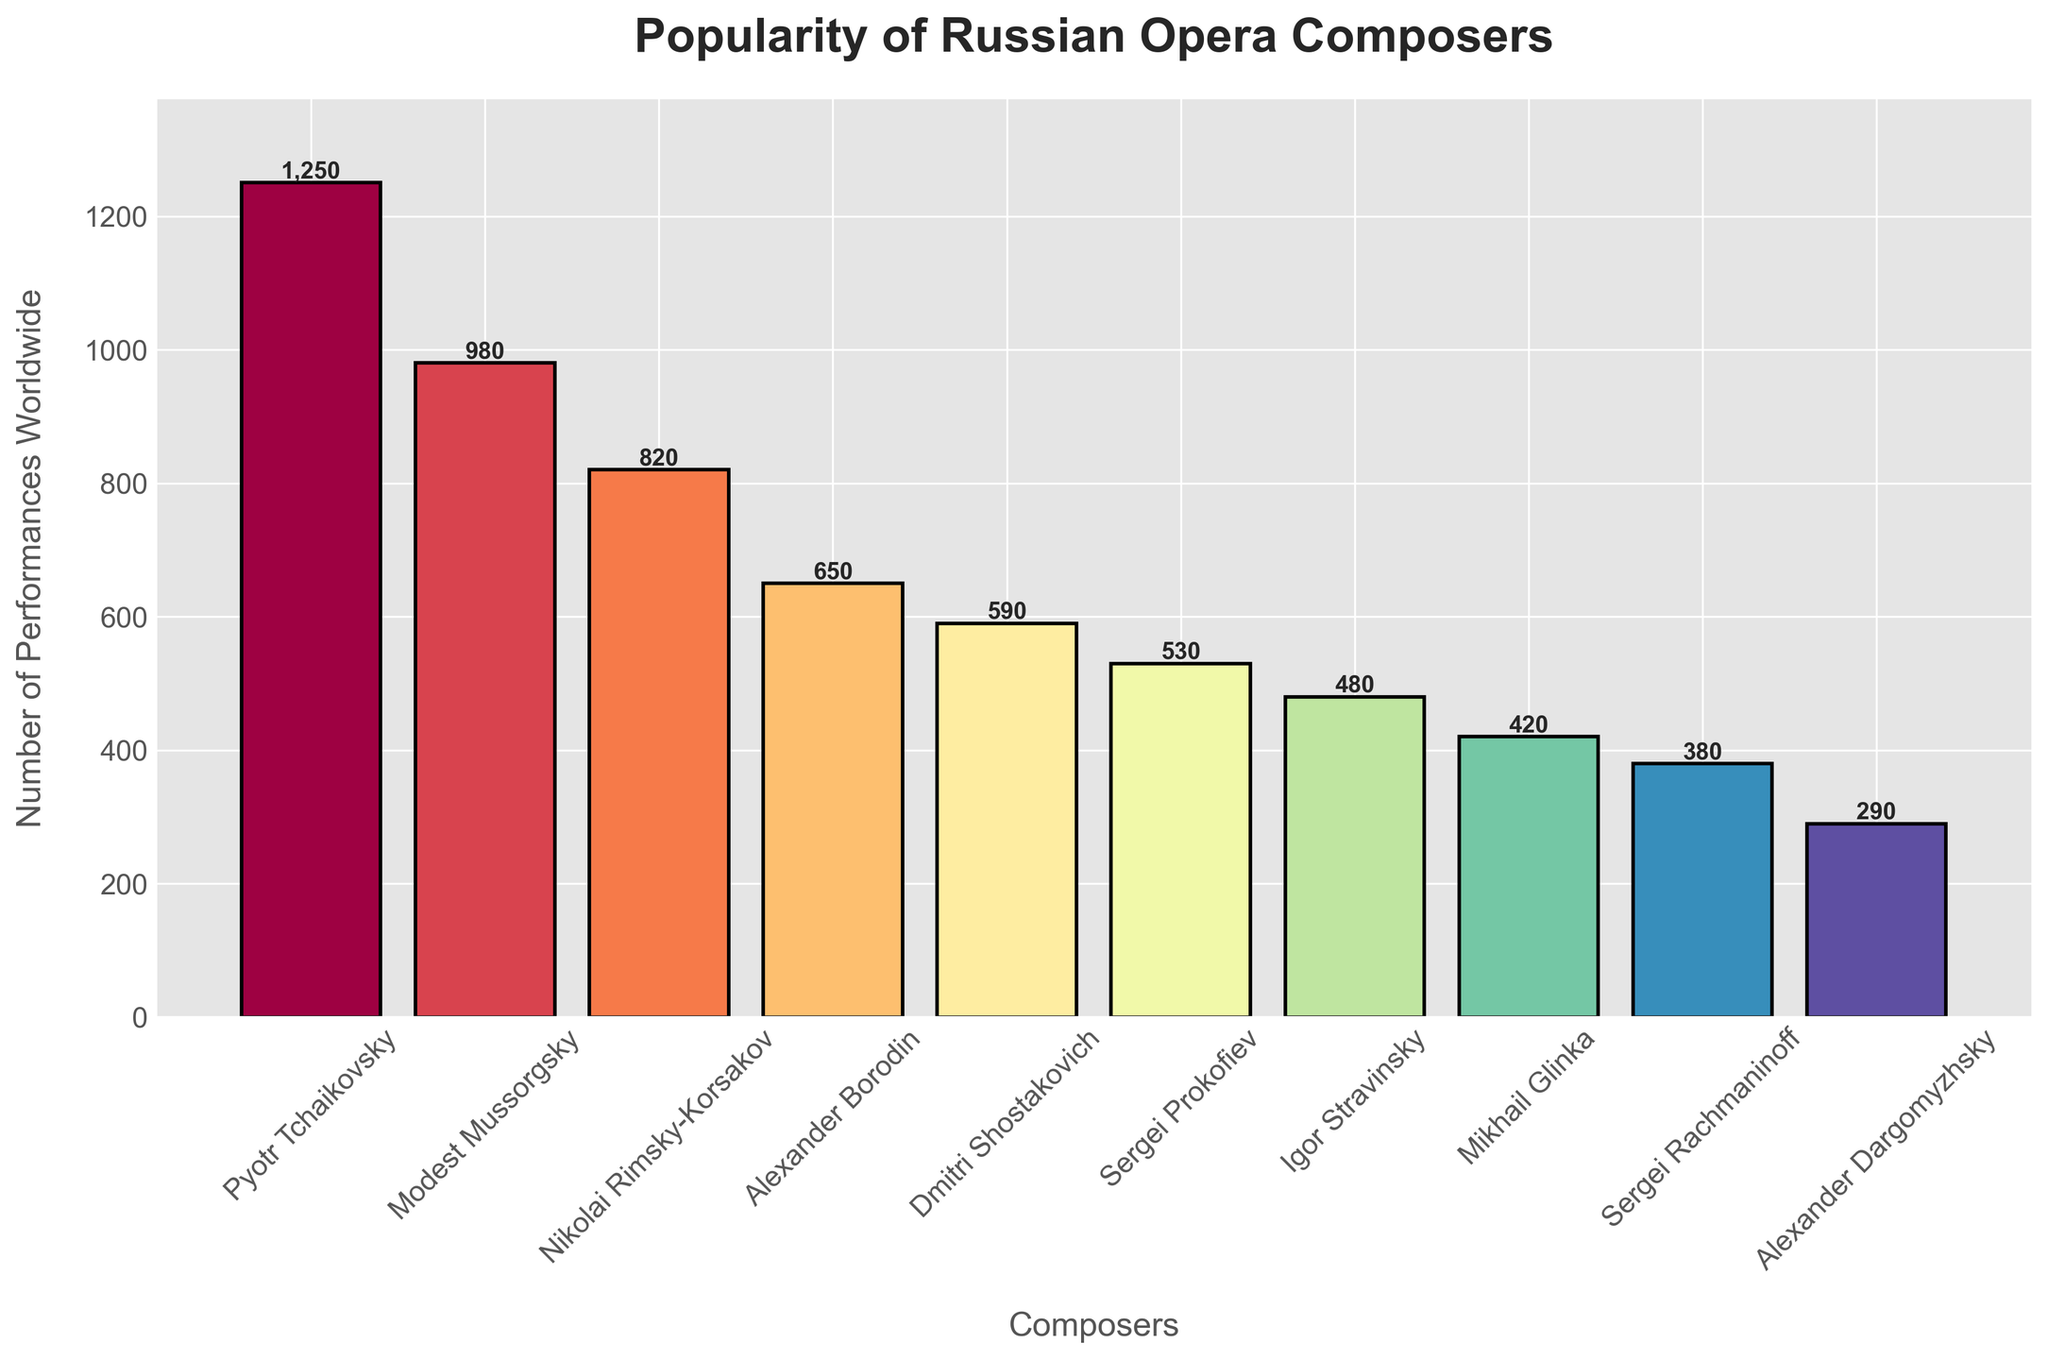Which composer has the highest number of performances? The bar corresponding to "Pyotr Tchaikovsky" is the tallest in the figure. This indicates he has the highest number of performances.
Answer: Pyotr Tchaikovsky Which composer has the lowest number of performances? The bar corresponding to "Alexander Dargomyzhsky" is the shortest in the figure. This indicates he has the lowest number of performances.
Answer: Alexander Dargomyzhsky By how many performances does Modest Mussorgsky exceed Alexander Borodin? Mussorgsky has 980 performances, and Borodin has 650 performances. Subtract 650 from 980 to get the difference.
Answer: 330 Which three composers have between 400 and 600 performances, and how many performances do they each have? From the chart, the composers in this range are Dmitri Shostakovich (590), Sergei Prokofiev (530), and Mikhail Glinka (420).
Answer: Dmitri Shostakovich: 590, Sergei Prokofiev: 530, Mikhail Glinka: 420 Is the number of performances of Nikolai Rimsky-Korsakov closer to Modest Mussorgsky or to Alexander Borodin? Rimsky-Korsakov has 820 performances. The difference with Mussorgsky (980 performances) is 160, while the difference with Borodin (650 performances) is also 170. So, he is equidistant from Mussorgsky and Borodin in terms of performances.
Answer: Both (equidistant) Which composers have more than 700 performances worldwide? The bars that are taller than 700 performances correspond to Pyotr Tchaikovsky, Modest Mussorgsky, and Nikolai Rimsky-Korsakov.
Answer: Pyotr Tchaikovsky, Modest Mussorgsky, Nikolai Rimsky-Korsakov Which composer has approximately half the number of performances as Pyotr Tchaikovsky and how many performances do they have? Pyotr Tchaikovsky has 1250 performances. Half of this is 625. The closest performer is Alexander Borodin with 650 performances.
Answer: Alexander Borodin: 650 What is the total number of performances for all ten composers? Sum the number of performances for each composer: 1250 (Tchaikovsky) + 980 (Mussorgsky) + 820 (Rimsky-Korsakov) + 650 (Borodin) + 590 (Shostakovich) + 530 (Prokofiev) + 480 (Stravinsky) + 420 (Glinka) + 380 (Rachmaninoff) + 290 (Dargomyzhsky) = 6390 performances.
Answer: 6390 How many composers have fewer than 500 performances? The bars shorter than the 500 performance mark belong to Igor Stravinsky (480), Mikhail Glinka (420), Sergei Rachmaninoff (380), and Alexander Dargomyzhsky (290). Thus, there are 4 composers with fewer than 500 performances.
Answer: 4 What is the average number of performances for all composers? The total number of performances is 6390 for 10 composers. The average is 6390 divided by 10.
Answer: 639 